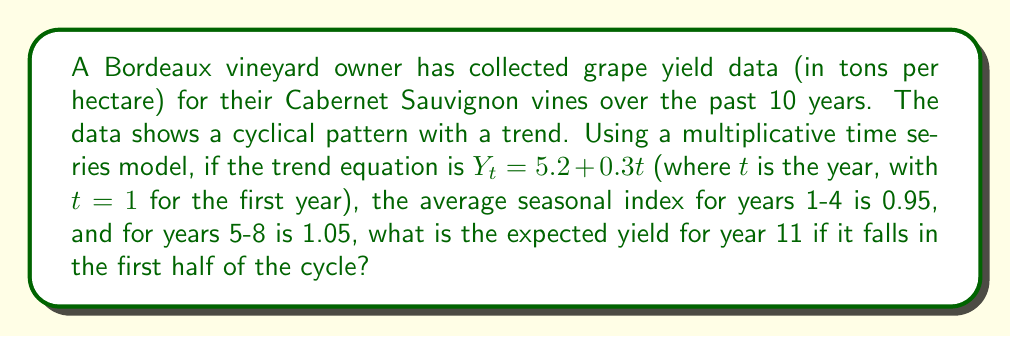Could you help me with this problem? To solve this problem, we'll use the multiplicative time series model, which is expressed as:

$$Y = T \times S \times I$$

Where:
$Y$ is the expected yield
$T$ is the trend component
$S$ is the seasonal component
$I$ is the irregular component (assumed to be 1 for forecasting)

Steps to solve:

1. Calculate the trend component for year 11:
   $$T_{11} = 5.2 + 0.3(11) = 5.2 + 3.3 = 8.5$$

2. Determine the seasonal index:
   Since year 11 falls in the first half of the cycle (years 1-4), we use the average seasonal index of 0.95.

3. Apply the multiplicative model:
   $$Y_{11} = T_{11} \times S \times I$$
   $$Y_{11} = 8.5 \times 0.95 \times 1$$
   $$Y_{11} = 8.075$$

Therefore, the expected yield for year 11 is 8.075 tons per hectare.
Answer: 8.075 tons per hectare 